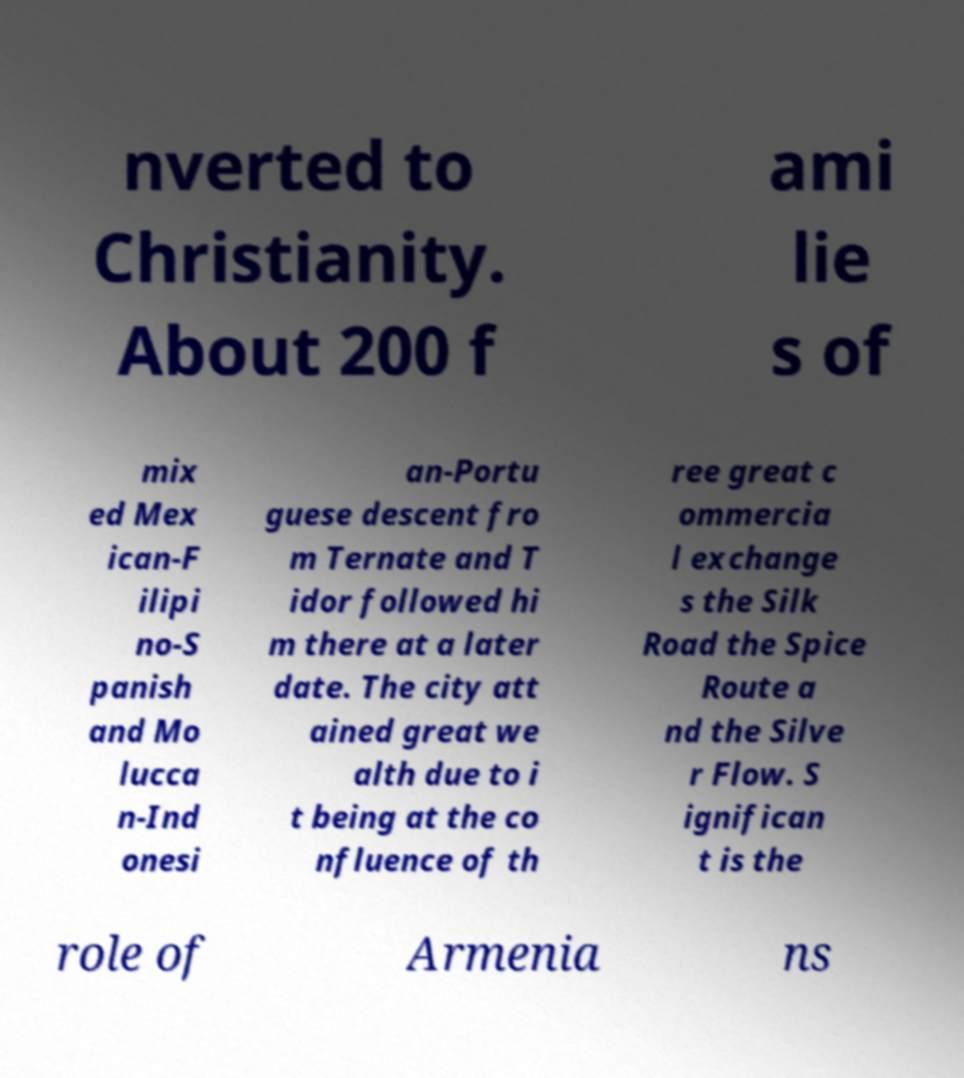Please read and relay the text visible in this image. What does it say? nverted to Christianity. About 200 f ami lie s of mix ed Mex ican-F ilipi no-S panish and Mo lucca n-Ind onesi an-Portu guese descent fro m Ternate and T idor followed hi m there at a later date. The city att ained great we alth due to i t being at the co nfluence of th ree great c ommercia l exchange s the Silk Road the Spice Route a nd the Silve r Flow. S ignifican t is the role of Armenia ns 